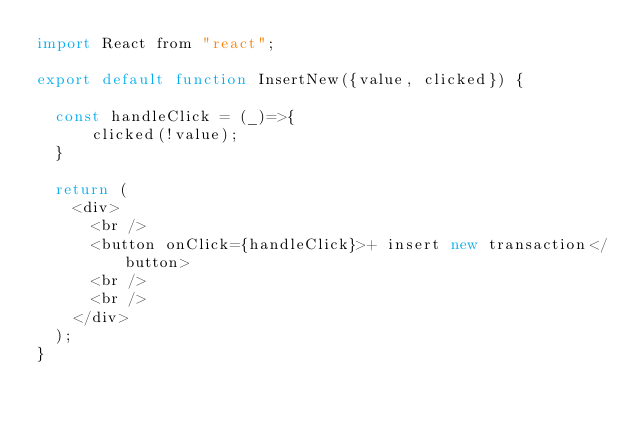Convert code to text. <code><loc_0><loc_0><loc_500><loc_500><_JavaScript_>import React from "react";

export default function InsertNew({value, clicked}) {

  const handleClick = (_)=>{
      clicked(!value);
  }

  return (
    <div>
      <br />
      <button onClick={handleClick}>+ insert new transaction</button>
      <br />
      <br />
    </div>
  );
}
</code> 